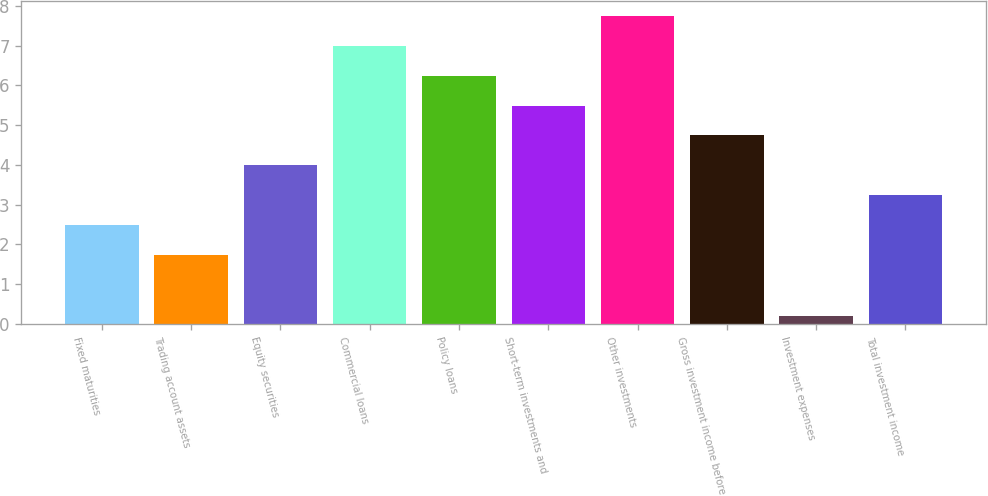Convert chart to OTSL. <chart><loc_0><loc_0><loc_500><loc_500><bar_chart><fcel>Fixed maturities<fcel>Trading account assets<fcel>Equity securities<fcel>Commercial loans<fcel>Policy loans<fcel>Short-term investments and<fcel>Other investments<fcel>Gross investment income before<fcel>Investment expenses<fcel>Total investment income<nl><fcel>2.49<fcel>1.74<fcel>3.99<fcel>6.99<fcel>6.24<fcel>5.49<fcel>7.74<fcel>4.74<fcel>0.21<fcel>3.24<nl></chart> 